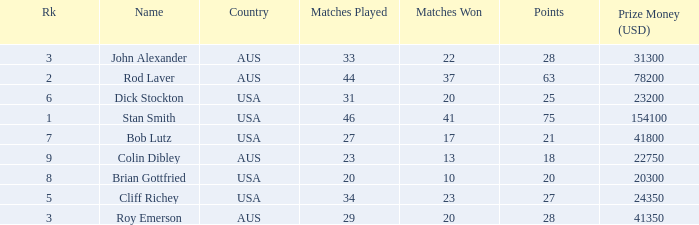How much prize money (in usd) did bob lutz win 41800.0. 